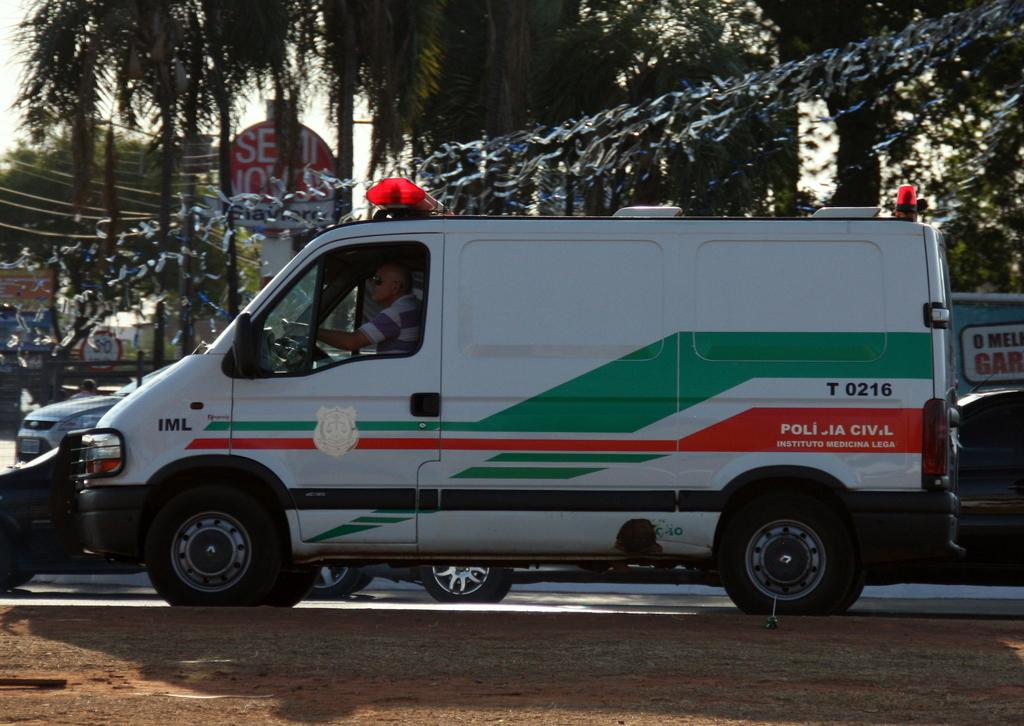Provide a one-sentence caption for the provided image. A white van with lights on top and the marking of Policia Civil. 